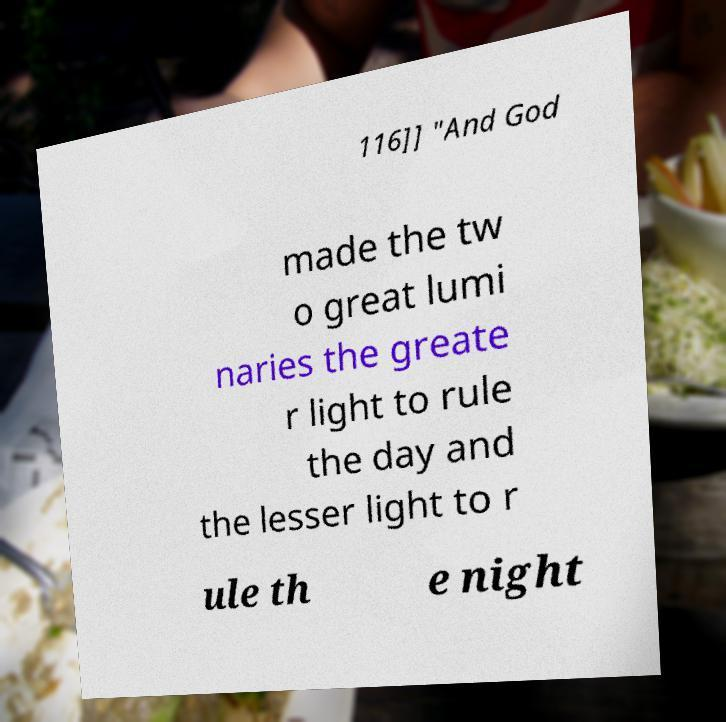Can you read and provide the text displayed in the image?This photo seems to have some interesting text. Can you extract and type it out for me? 116]] "And God made the tw o great lumi naries the greate r light to rule the day and the lesser light to r ule th e night 